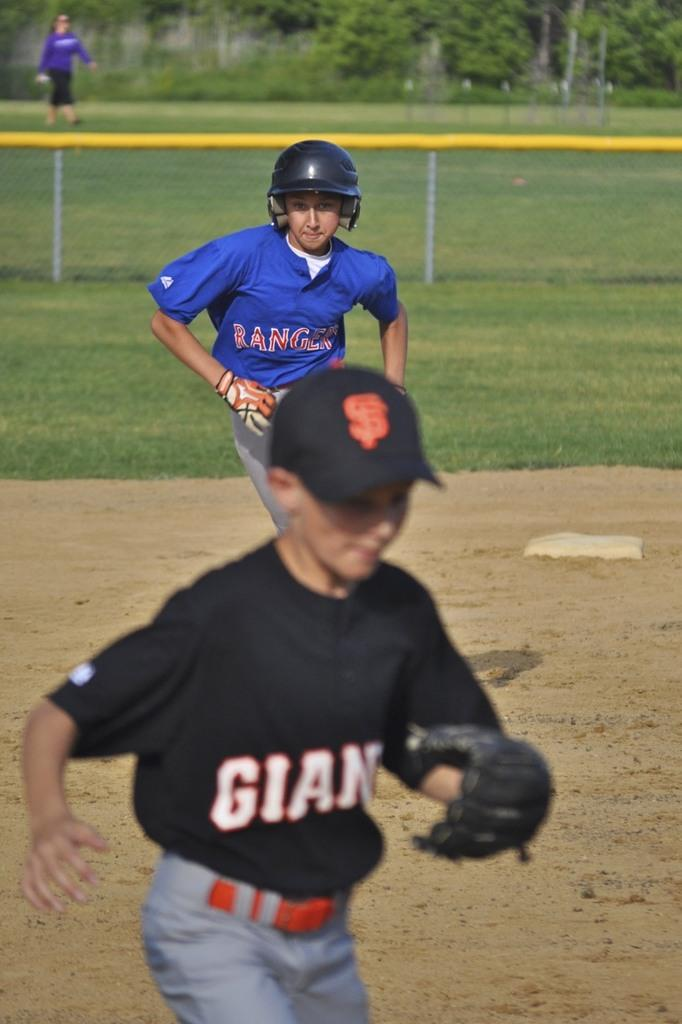<image>
Present a compact description of the photo's key features. a few players including one with a Giants uniform 